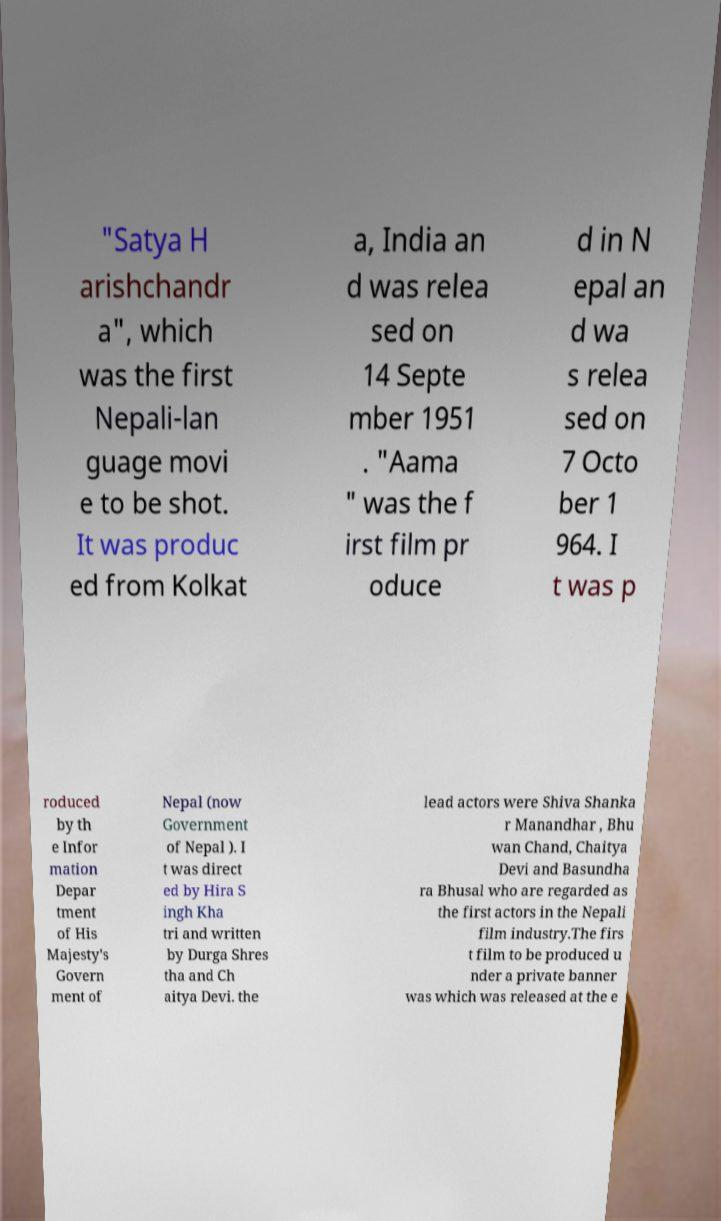Could you assist in decoding the text presented in this image and type it out clearly? "Satya H arishchandr a", which was the first Nepali-lan guage movi e to be shot. It was produc ed from Kolkat a, India an d was relea sed on 14 Septe mber 1951 . "Aama " was the f irst film pr oduce d in N epal an d wa s relea sed on 7 Octo ber 1 964. I t was p roduced by th e Infor mation Depar tment of His Majesty's Govern ment of Nepal (now Government of Nepal ). I t was direct ed by Hira S ingh Kha tri and written by Durga Shres tha and Ch aitya Devi. the lead actors were Shiva Shanka r Manandhar , Bhu wan Chand, Chaitya Devi and Basundha ra Bhusal who are regarded as the first actors in the Nepali film industry.The firs t film to be produced u nder a private banner was which was released at the e 